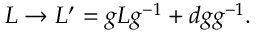Convert formula to latex. <formula><loc_0><loc_0><loc_500><loc_500>L \rightarrow L ^ { \prime } = g L g ^ { - 1 } + d g g ^ { - 1 } .</formula> 